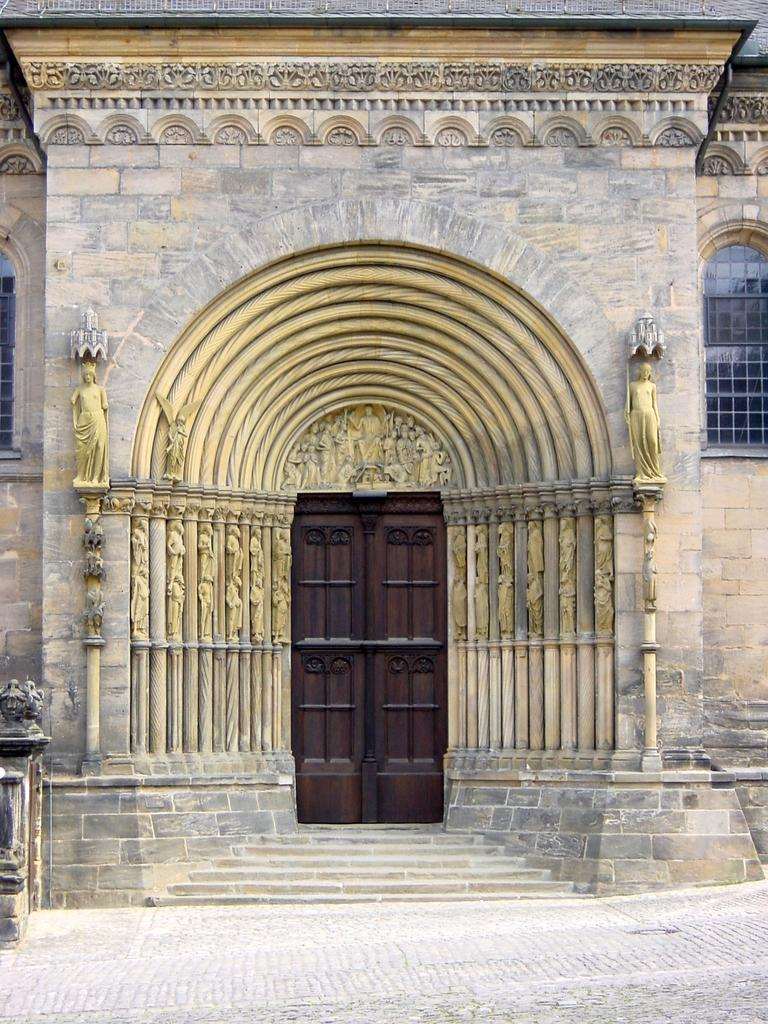What can be seen on the wall in the image? There are sculptures on the wall in the image. What is a feature that allows access to different levels in the image? There are stairs in the image. What is a structure that provides entry or exit in the image? There is a door in the image. What can be seen on the ground in the image? The ground is visible in the image. What is a vertical structure in the image? There is a pole in the image. What allows light to enter the building in the image? There are windows in the image. What is the title of the land depicted in the image? There is no land depicted in the image, and therefore no title can be determined. What is the recess used for in the image? There is no recess present in the image. 